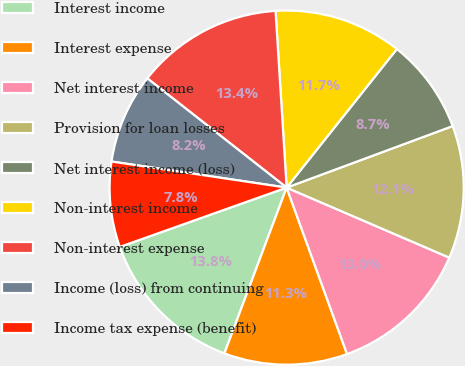<chart> <loc_0><loc_0><loc_500><loc_500><pie_chart><fcel>Interest income<fcel>Interest expense<fcel>Net interest income<fcel>Provision for loan losses<fcel>Net interest income (loss)<fcel>Non-interest income<fcel>Non-interest expense<fcel>Income (loss) from continuing<fcel>Income tax expense (benefit)<nl><fcel>13.85%<fcel>11.26%<fcel>12.99%<fcel>12.12%<fcel>8.66%<fcel>11.69%<fcel>13.42%<fcel>8.23%<fcel>7.79%<nl></chart> 